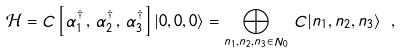<formula> <loc_0><loc_0><loc_500><loc_500>\mathcal { H } = C \left [ \alpha _ { 1 } ^ { \dagger } \, , \, \alpha _ { 2 } ^ { \dagger } \, , \, \alpha _ { 3 } ^ { \dagger } \right ] | 0 , 0 , 0 \rangle = \bigoplus _ { n _ { 1 } , n _ { 2 } , n _ { 3 } \in N _ { 0 } } \, C | n _ { 1 } , n _ { 2 } , n _ { 3 } \rangle \ ,</formula> 